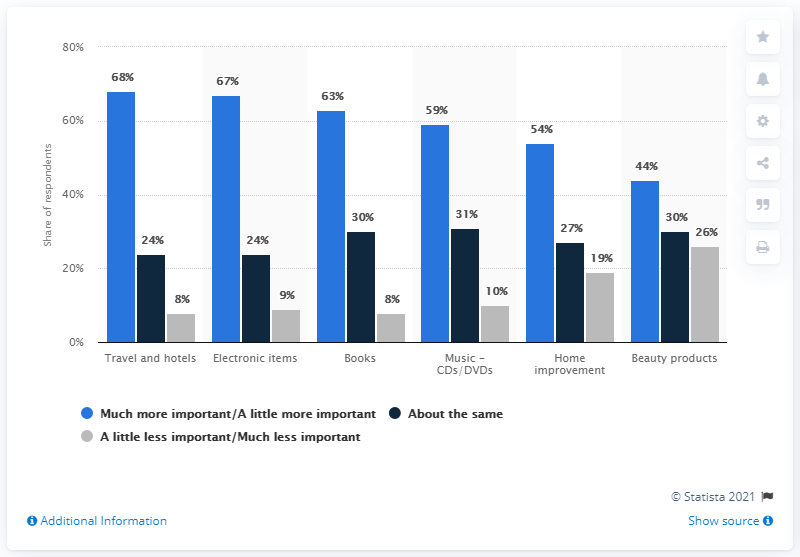List a handful of essential elements in this visual. In the travel and hotel sector, it is widely considered to be the most critical. Of the sectors with over 50% of reviews indicating that they consider them important, how many have over 50% of reviews rating them highly? 